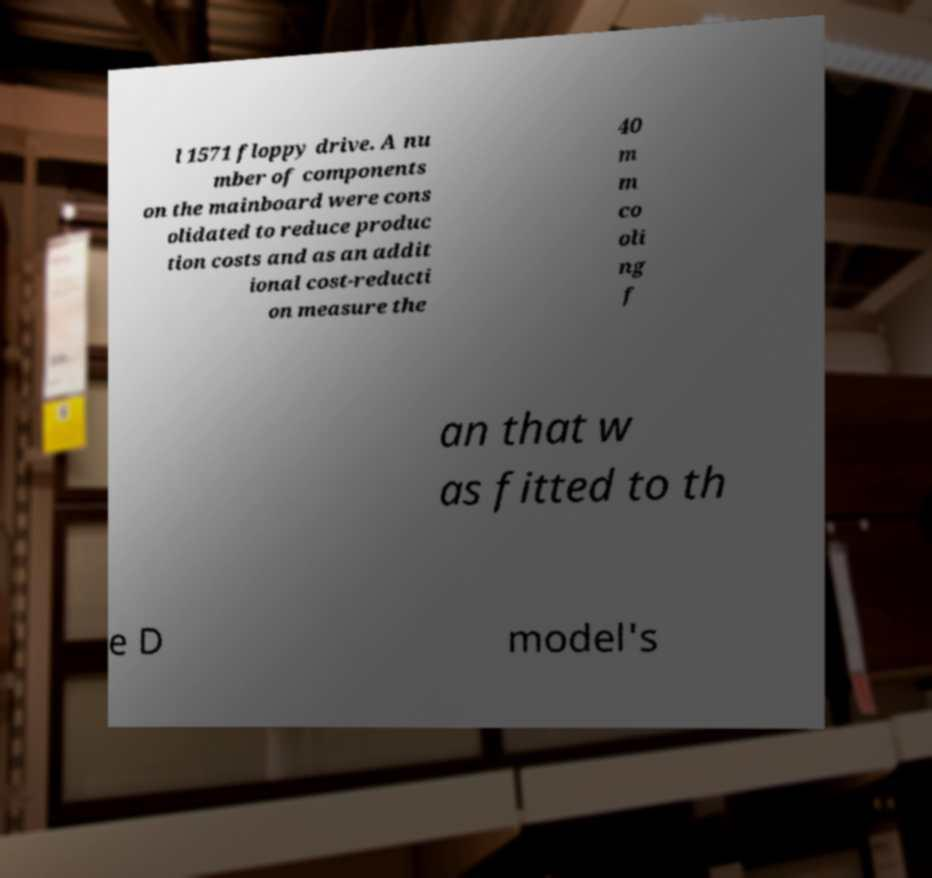What messages or text are displayed in this image? I need them in a readable, typed format. l 1571 floppy drive. A nu mber of components on the mainboard were cons olidated to reduce produc tion costs and as an addit ional cost-reducti on measure the 40 m m co oli ng f an that w as fitted to th e D model's 